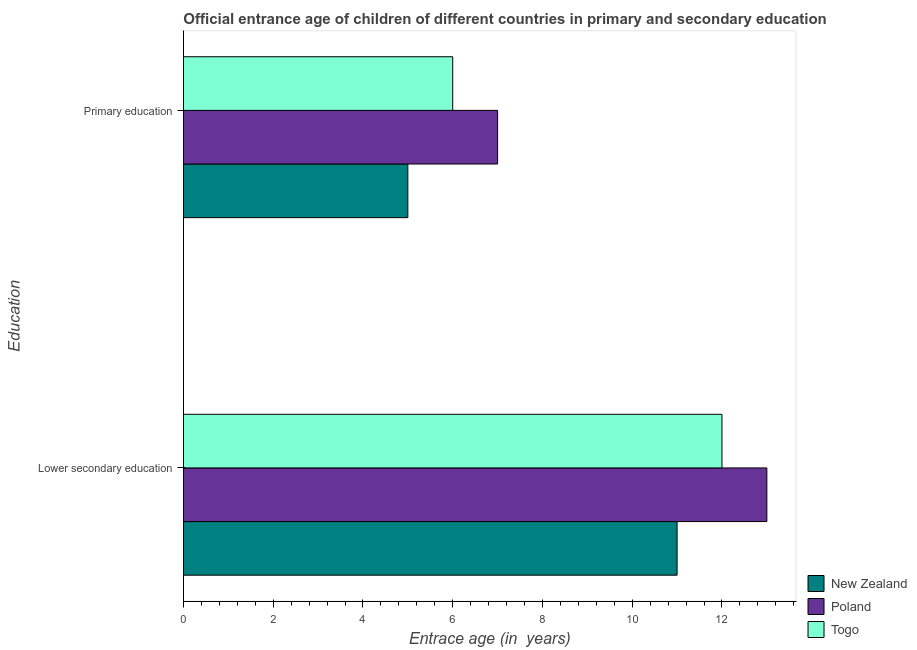How many groups of bars are there?
Make the answer very short. 2. Are the number of bars on each tick of the Y-axis equal?
Provide a succinct answer. Yes. What is the label of the 2nd group of bars from the top?
Your answer should be very brief. Lower secondary education. What is the entrance age of children in lower secondary education in New Zealand?
Keep it short and to the point. 11. Across all countries, what is the maximum entrance age of chiildren in primary education?
Provide a short and direct response. 7. Across all countries, what is the minimum entrance age of children in lower secondary education?
Your answer should be compact. 11. In which country was the entrance age of children in lower secondary education minimum?
Ensure brevity in your answer.  New Zealand. What is the total entrance age of children in lower secondary education in the graph?
Keep it short and to the point. 36. What is the difference between the entrance age of children in lower secondary education in New Zealand and that in Poland?
Provide a succinct answer. -2. What is the difference between the entrance age of children in lower secondary education in Poland and the entrance age of chiildren in primary education in Togo?
Ensure brevity in your answer.  7. In how many countries, is the entrance age of children in lower secondary education greater than the average entrance age of children in lower secondary education taken over all countries?
Ensure brevity in your answer.  1. What does the 1st bar from the top in Primary education represents?
Ensure brevity in your answer.  Togo. Does the graph contain any zero values?
Provide a short and direct response. No. What is the title of the graph?
Your answer should be compact. Official entrance age of children of different countries in primary and secondary education. What is the label or title of the X-axis?
Offer a very short reply. Entrace age (in  years). What is the label or title of the Y-axis?
Offer a terse response. Education. What is the Entrace age (in  years) in New Zealand in Lower secondary education?
Provide a succinct answer. 11. What is the Entrace age (in  years) of Poland in Lower secondary education?
Your answer should be compact. 13. What is the Entrace age (in  years) of Togo in Lower secondary education?
Offer a very short reply. 12. What is the Entrace age (in  years) in Poland in Primary education?
Offer a very short reply. 7. Across all Education, what is the maximum Entrace age (in  years) in Poland?
Give a very brief answer. 13. Across all Education, what is the minimum Entrace age (in  years) of New Zealand?
Your response must be concise. 5. What is the total Entrace age (in  years) of New Zealand in the graph?
Make the answer very short. 16. What is the difference between the Entrace age (in  years) of Poland in Lower secondary education and that in Primary education?
Give a very brief answer. 6. What is the difference between the Entrace age (in  years) of Togo in Lower secondary education and that in Primary education?
Keep it short and to the point. 6. What is the difference between the Entrace age (in  years) in Poland in Lower secondary education and the Entrace age (in  years) in Togo in Primary education?
Offer a terse response. 7. What is the average Entrace age (in  years) of New Zealand per Education?
Give a very brief answer. 8. What is the average Entrace age (in  years) in Poland per Education?
Provide a short and direct response. 10. What is the average Entrace age (in  years) in Togo per Education?
Your response must be concise. 9. What is the difference between the Entrace age (in  years) of Poland and Entrace age (in  years) of Togo in Lower secondary education?
Your response must be concise. 1. What is the difference between the Entrace age (in  years) in New Zealand and Entrace age (in  years) in Poland in Primary education?
Your response must be concise. -2. What is the difference between the Entrace age (in  years) in New Zealand and Entrace age (in  years) in Togo in Primary education?
Offer a terse response. -1. What is the ratio of the Entrace age (in  years) of New Zealand in Lower secondary education to that in Primary education?
Provide a short and direct response. 2.2. What is the ratio of the Entrace age (in  years) in Poland in Lower secondary education to that in Primary education?
Provide a succinct answer. 1.86. What is the difference between the highest and the second highest Entrace age (in  years) of Poland?
Your answer should be very brief. 6. What is the difference between the highest and the second highest Entrace age (in  years) of Togo?
Provide a succinct answer. 6. What is the difference between the highest and the lowest Entrace age (in  years) of Poland?
Offer a terse response. 6. What is the difference between the highest and the lowest Entrace age (in  years) in Togo?
Provide a succinct answer. 6. 